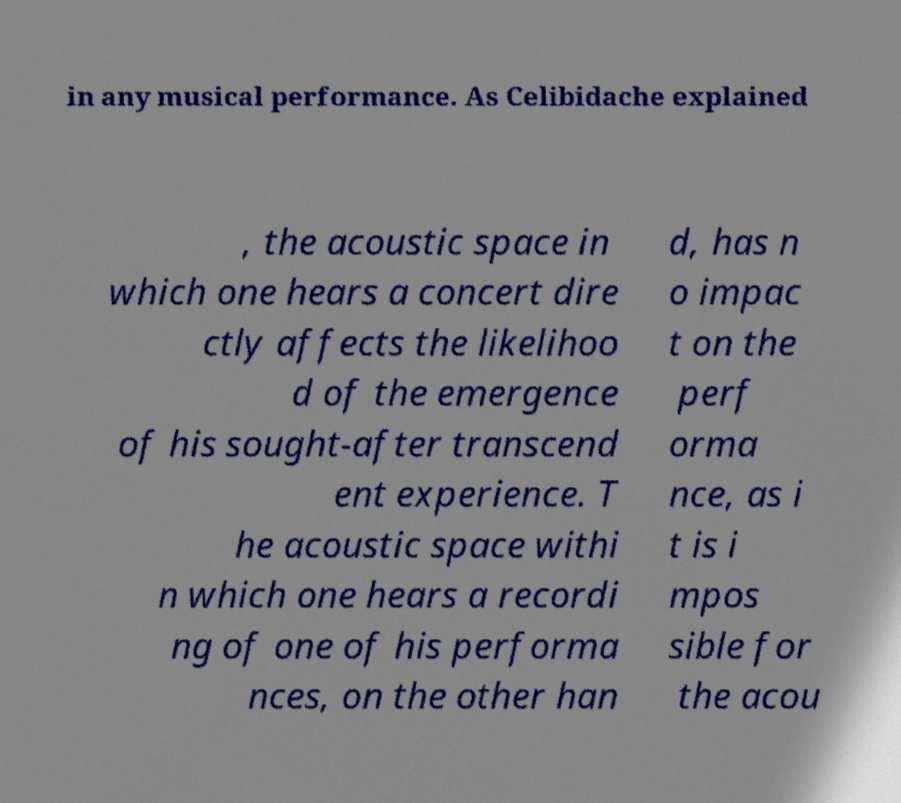Can you read and provide the text displayed in the image?This photo seems to have some interesting text. Can you extract and type it out for me? in any musical performance. As Celibidache explained , the acoustic space in which one hears a concert dire ctly affects the likelihoo d of the emergence of his sought-after transcend ent experience. T he acoustic space withi n which one hears a recordi ng of one of his performa nces, on the other han d, has n o impac t on the perf orma nce, as i t is i mpos sible for the acou 